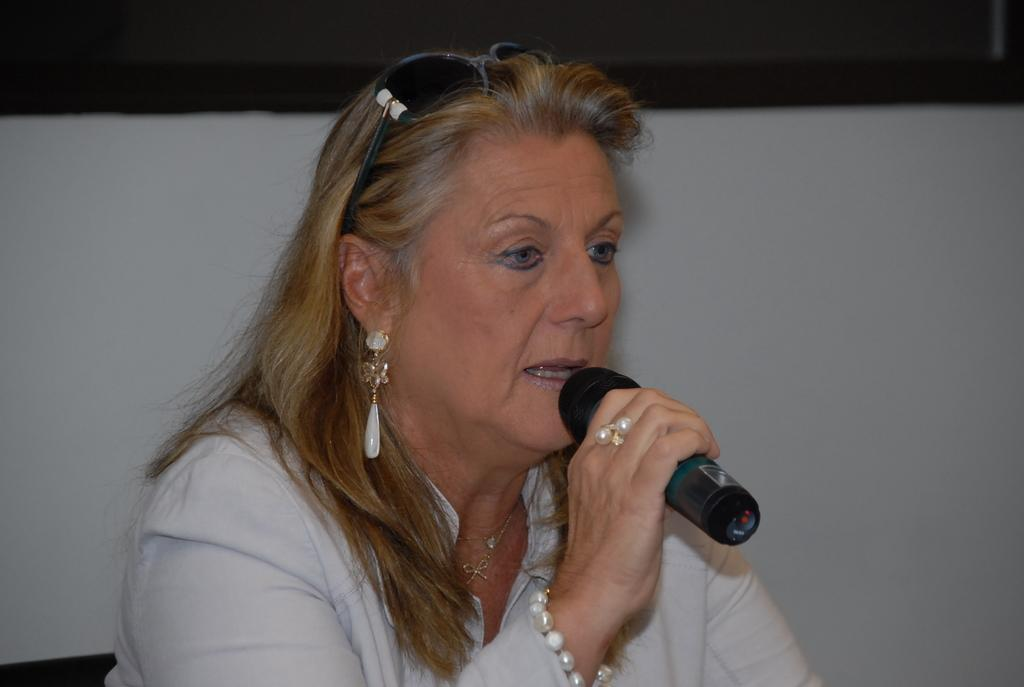Who is the main subject in the image? There is a woman in the image. What is the woman doing in the image? The woman is sitting on a chair and holding a mic in her hand. What type of brake can be seen on the woman's shoe in the image? There is no brake visible on the woman's shoe in the image. 